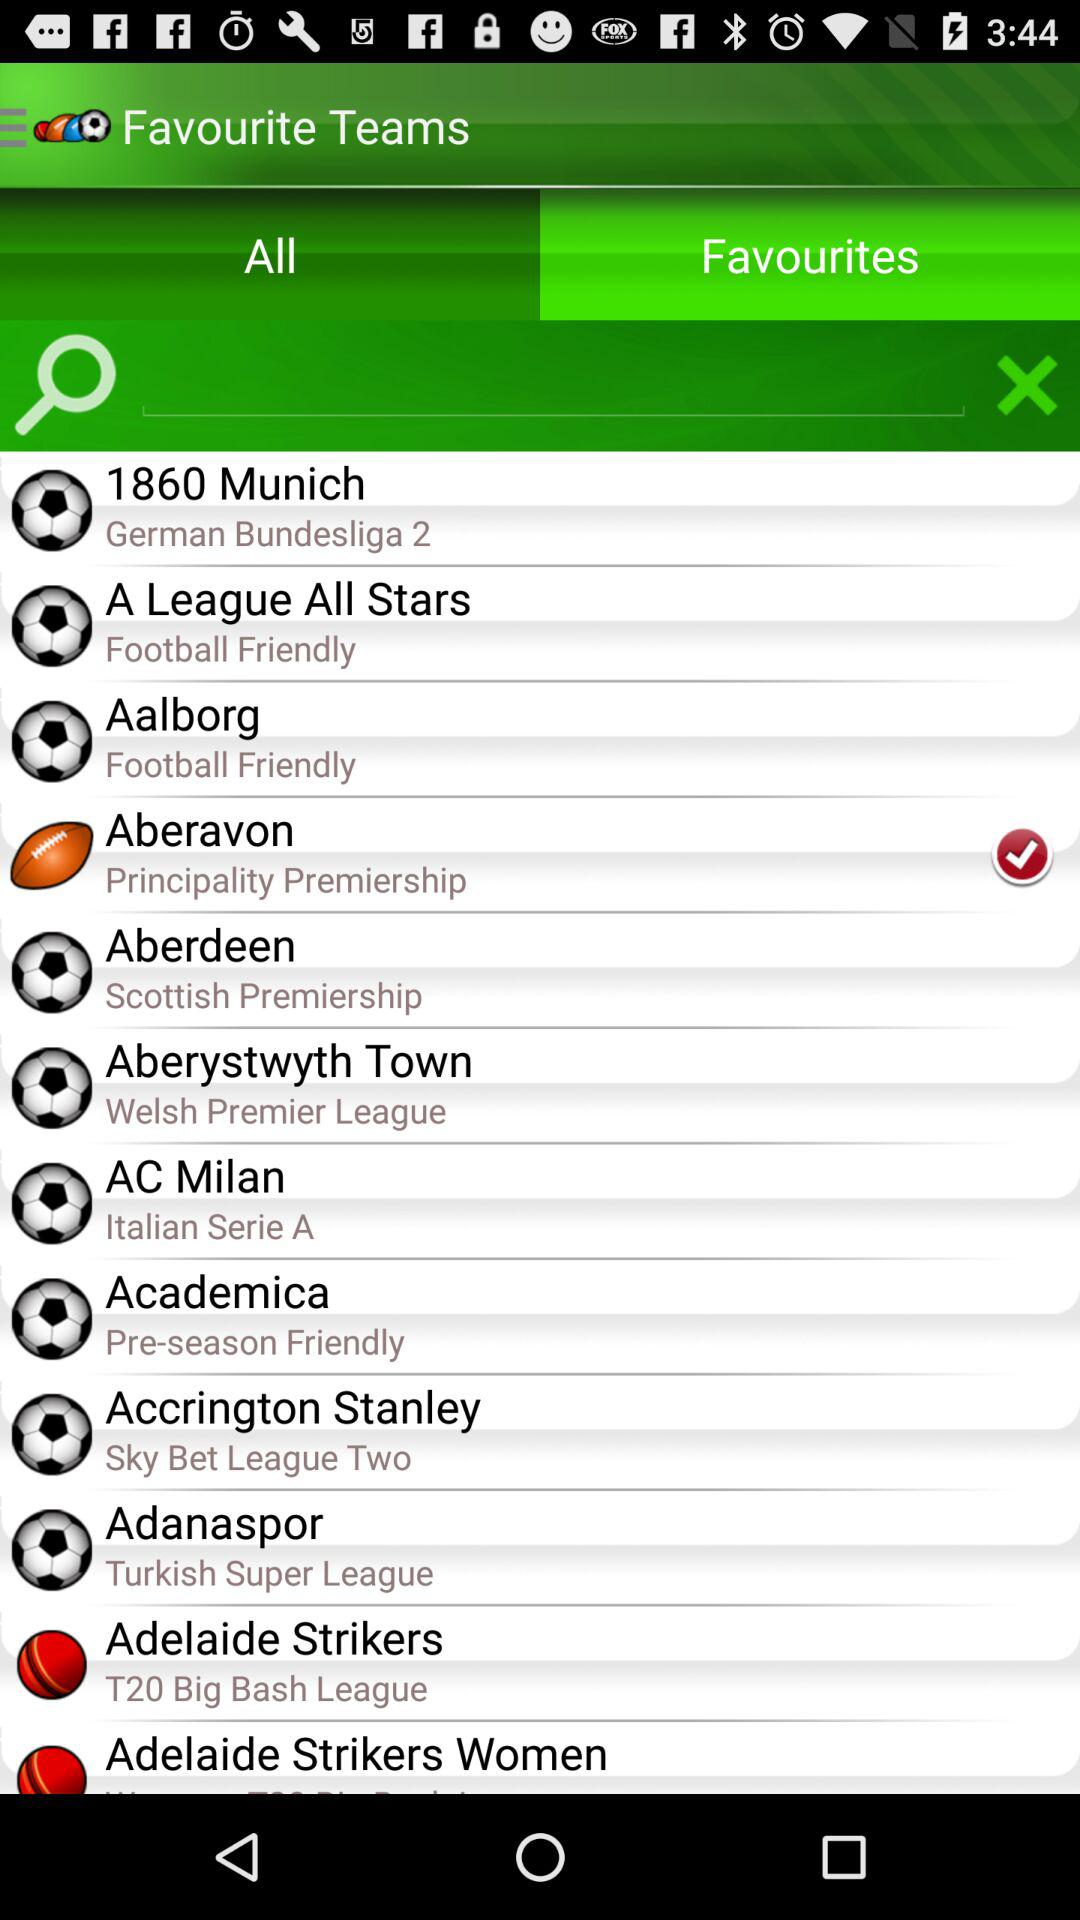What is the hometown field for "Aberdeen"?
When the provided information is insufficient, respond with <no answer>. <no answer> 